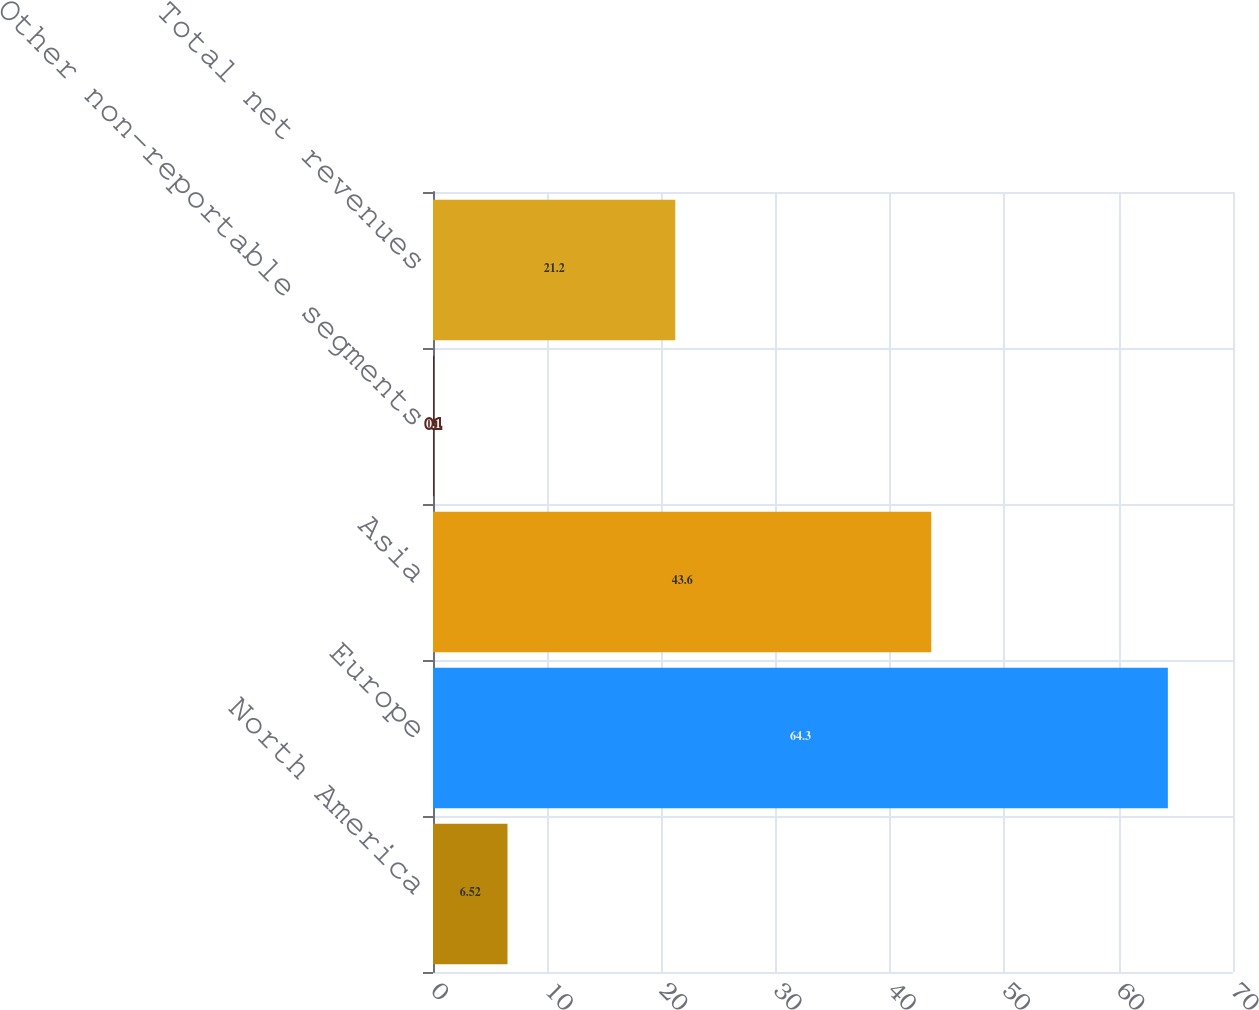<chart> <loc_0><loc_0><loc_500><loc_500><bar_chart><fcel>North America<fcel>Europe<fcel>Asia<fcel>Other non-reportable segments<fcel>Total net revenues<nl><fcel>6.52<fcel>64.3<fcel>43.6<fcel>0.1<fcel>21.2<nl></chart> 